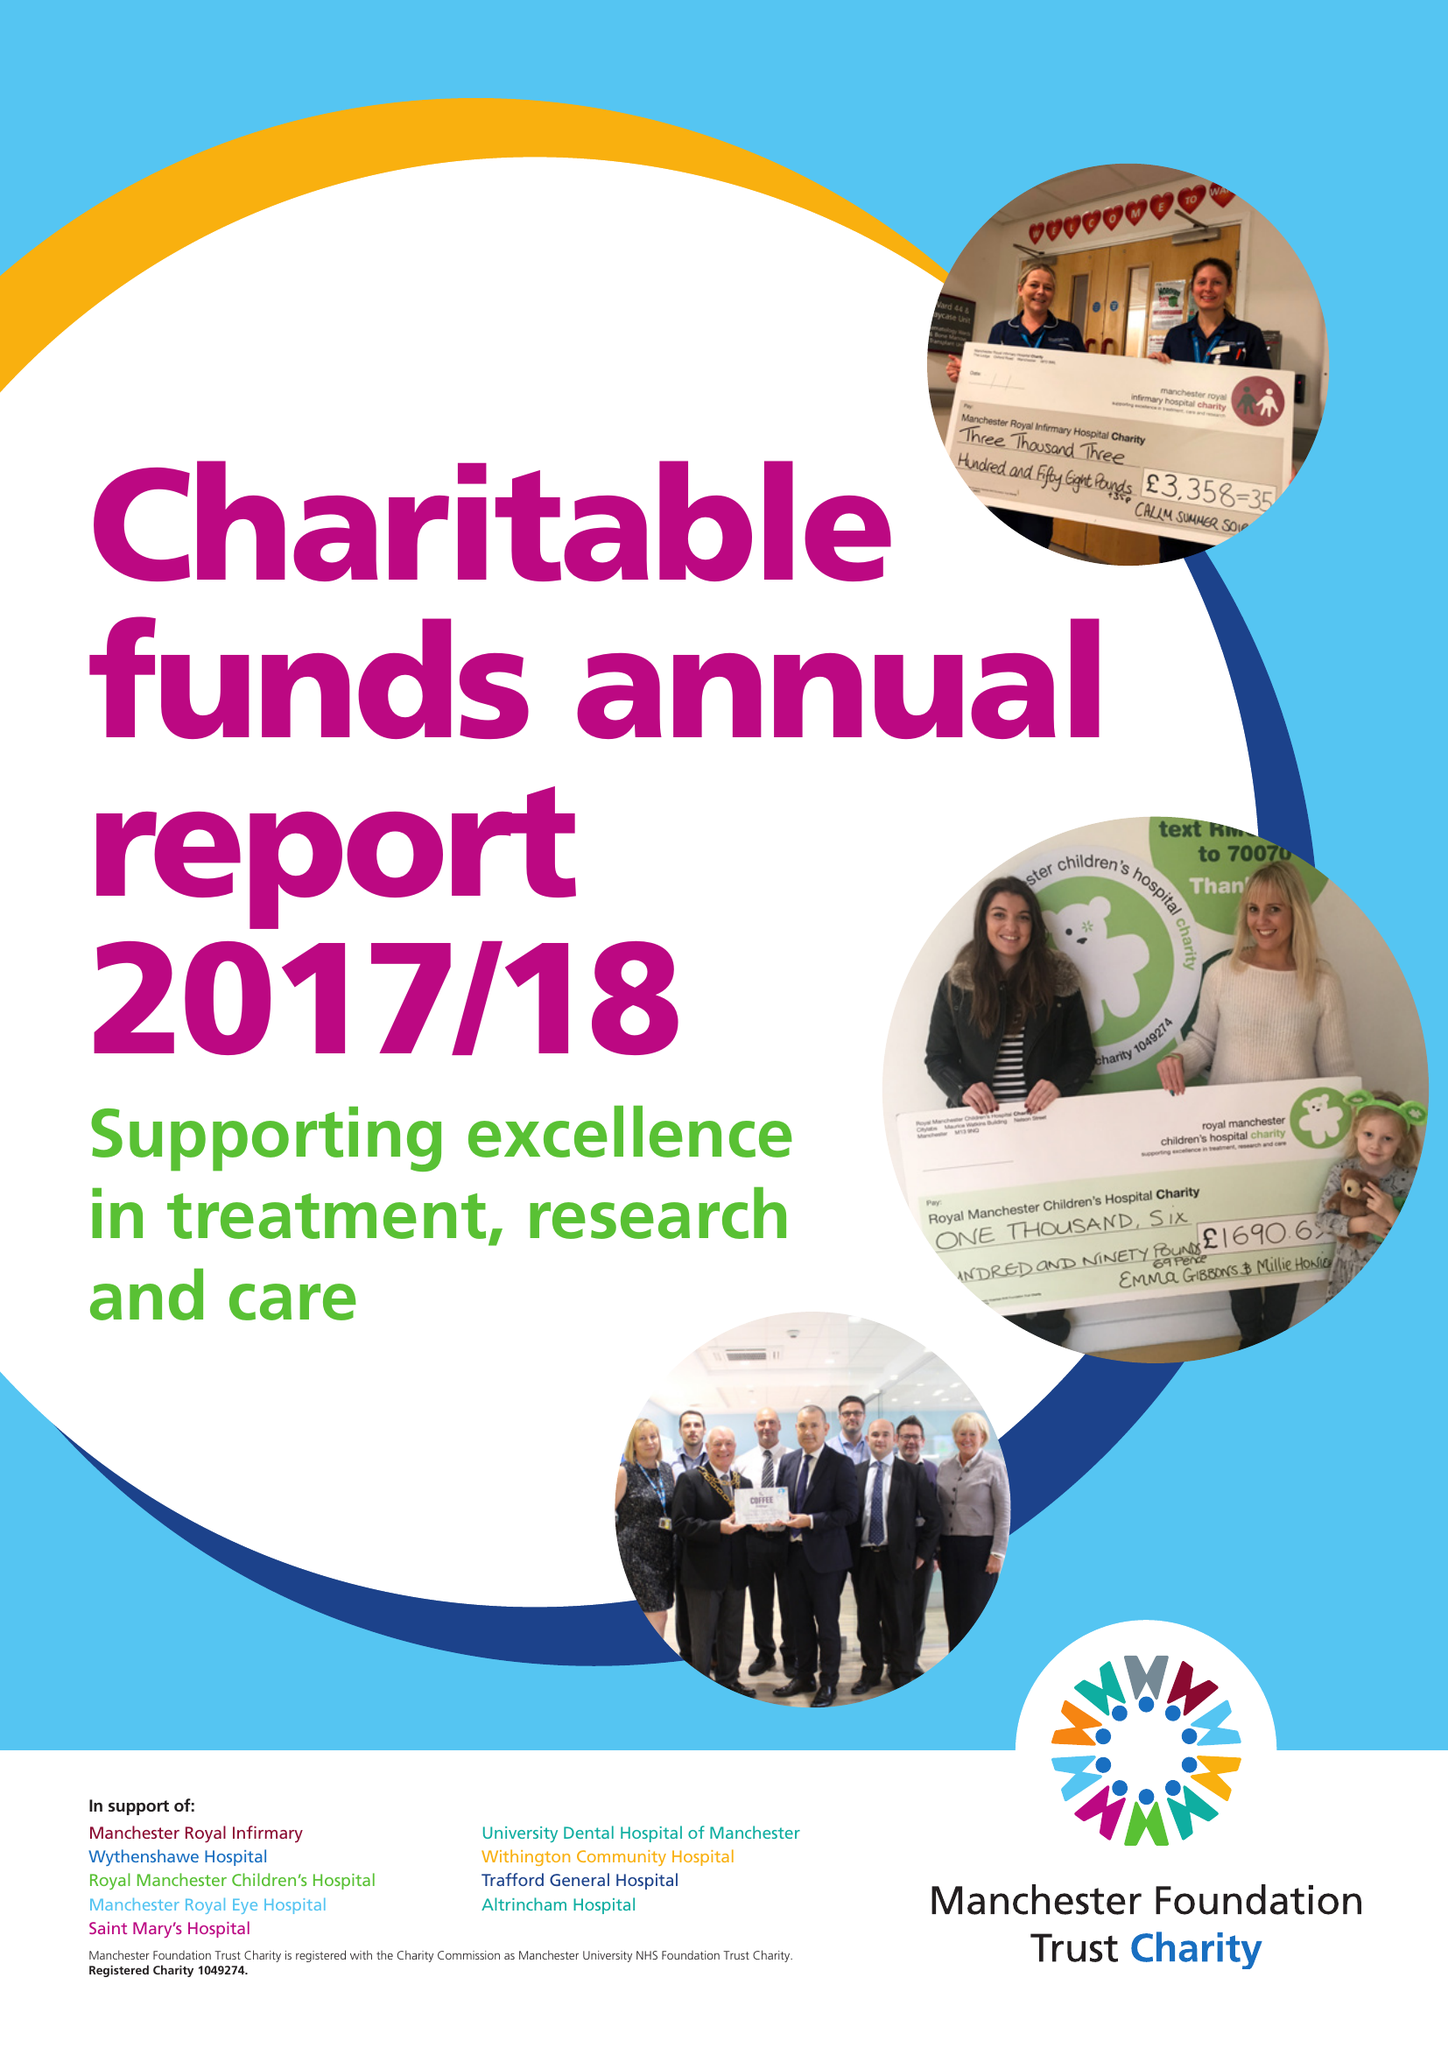What is the value for the address__post_town?
Answer the question using a single word or phrase. MANCHESTER 